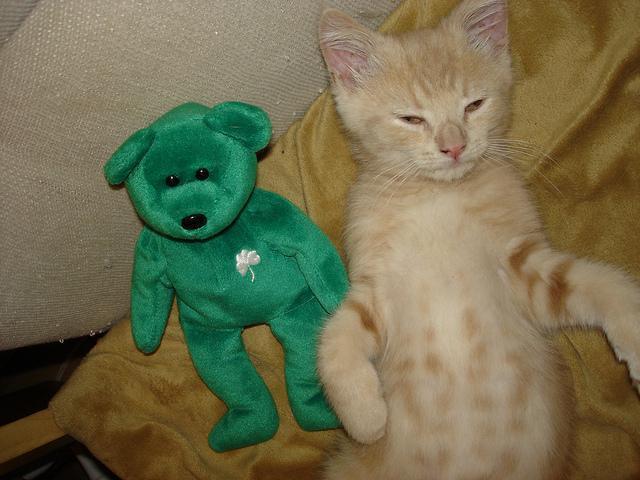How many cats are in the picture?
Give a very brief answer. 1. How many animals are in the image?
Give a very brief answer. 1. How many ears can you see?
Give a very brief answer. 4. How many kittens are there?
Give a very brief answer. 1. How many couches are in the photo?
Give a very brief answer. 2. How many people are wearing cap?
Give a very brief answer. 0. 